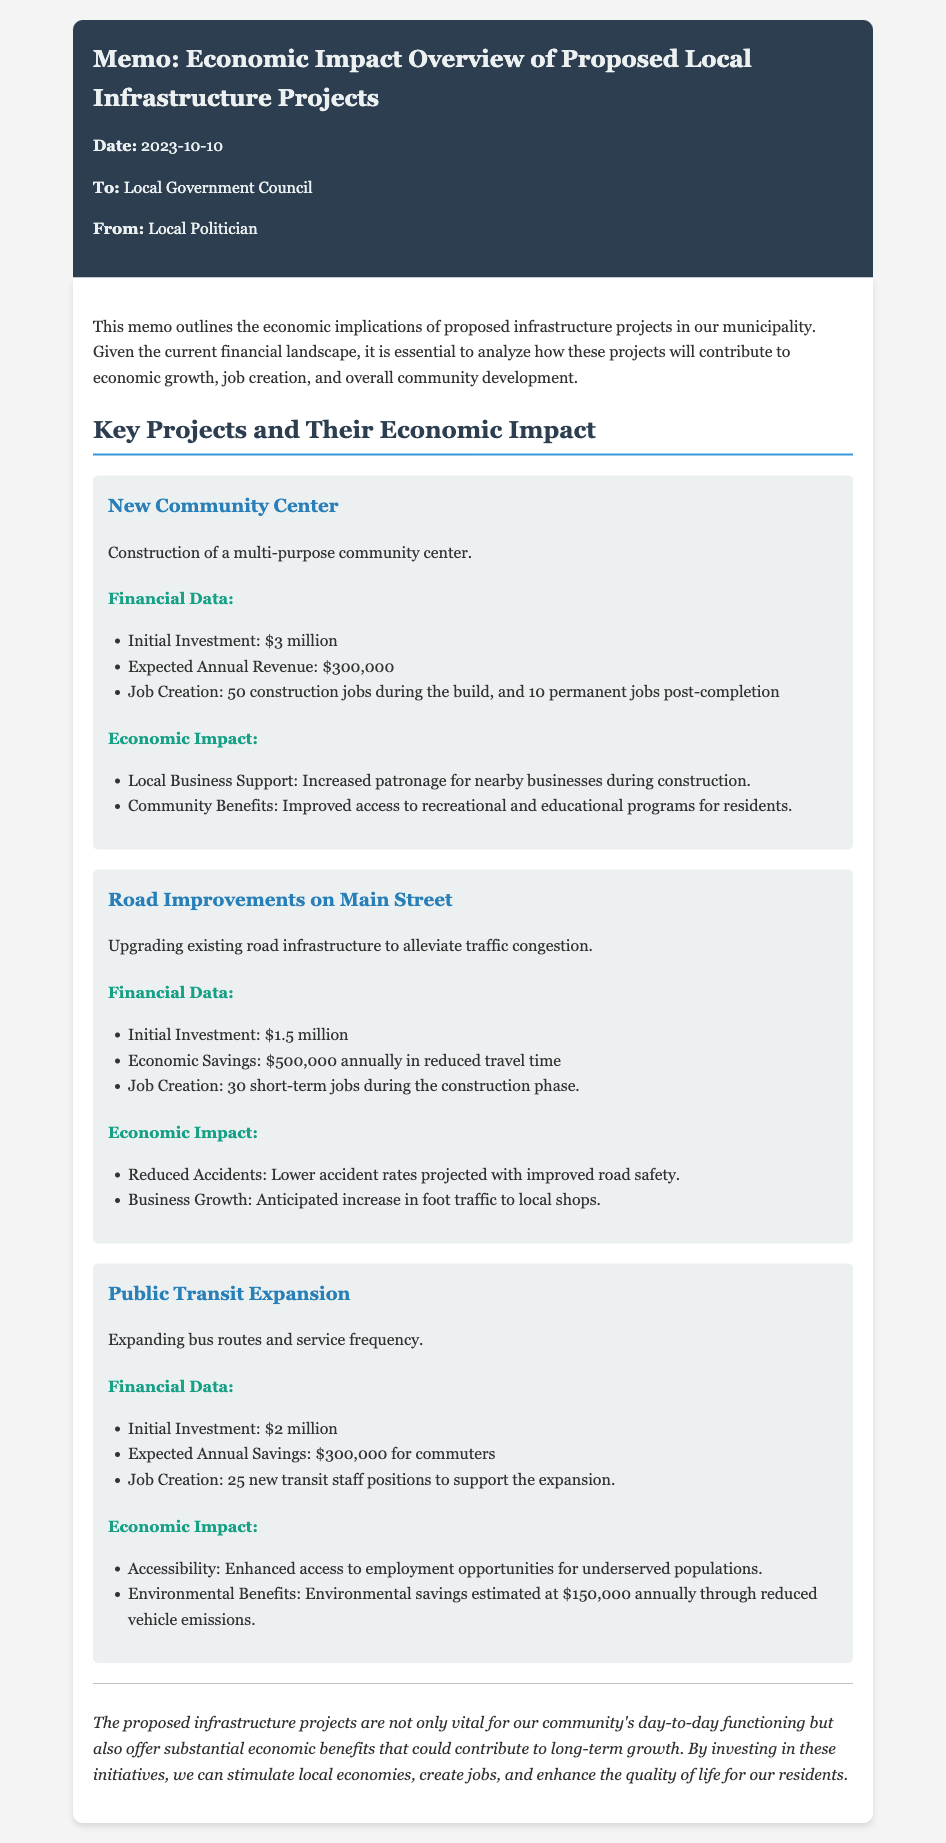What is the initial investment for the New Community Center? The initial investment is clearly stated as $3 million in the financial data section of the project description.
Answer: $3 million How many permanent jobs will be created by the New Community Center? The document indicates that 10 permanent jobs will be created once the New Community Center is completed.
Answer: 10 permanent jobs What is the expected annual revenue from the Road Improvements on Main Street? The document specifies the expected economic savings due to reduced travel time, which is $500,000 annually, indicating significant financial benefits of the project.
Answer: $500,000 What are the environmental savings estimated at for the Public Transit Expansion? The document provides a figure of $150,000 annually that reflects the environmental savings from reduced vehicle emissions.
Answer: $150,000 What is the total number of jobs created across all three projects? To find the total, we add the jobs from each project: 50 (New Community Center) + 30 (Road Improvements) + 25 (Public Transit) = 105.
Answer: 105 What community benefit is highlighted for the New Community Center? The memo mentions that the New Community Center will improve access to recreational and educational programs for residents, illustrating its community impact.
Answer: Improved access to recreational and educational programs What type of improvements are proposed for Main Street? The document specifically states that upgrading existing road infrastructure is aimed at alleviating traffic congestion.
Answer: Upgrading existing road infrastructure What is the date of this memo? The date is noted at the beginning of the memo as October 10, 2023.
Answer: October 10, 2023 